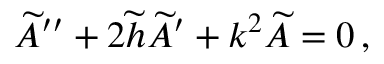Convert formula to latex. <formula><loc_0><loc_0><loc_500><loc_500>\widetilde { A } ^ { \prime \prime } + 2 \widetilde { h } \widetilde { A } ^ { \prime } + k ^ { 2 } \widetilde { A } = 0 \, ,</formula> 